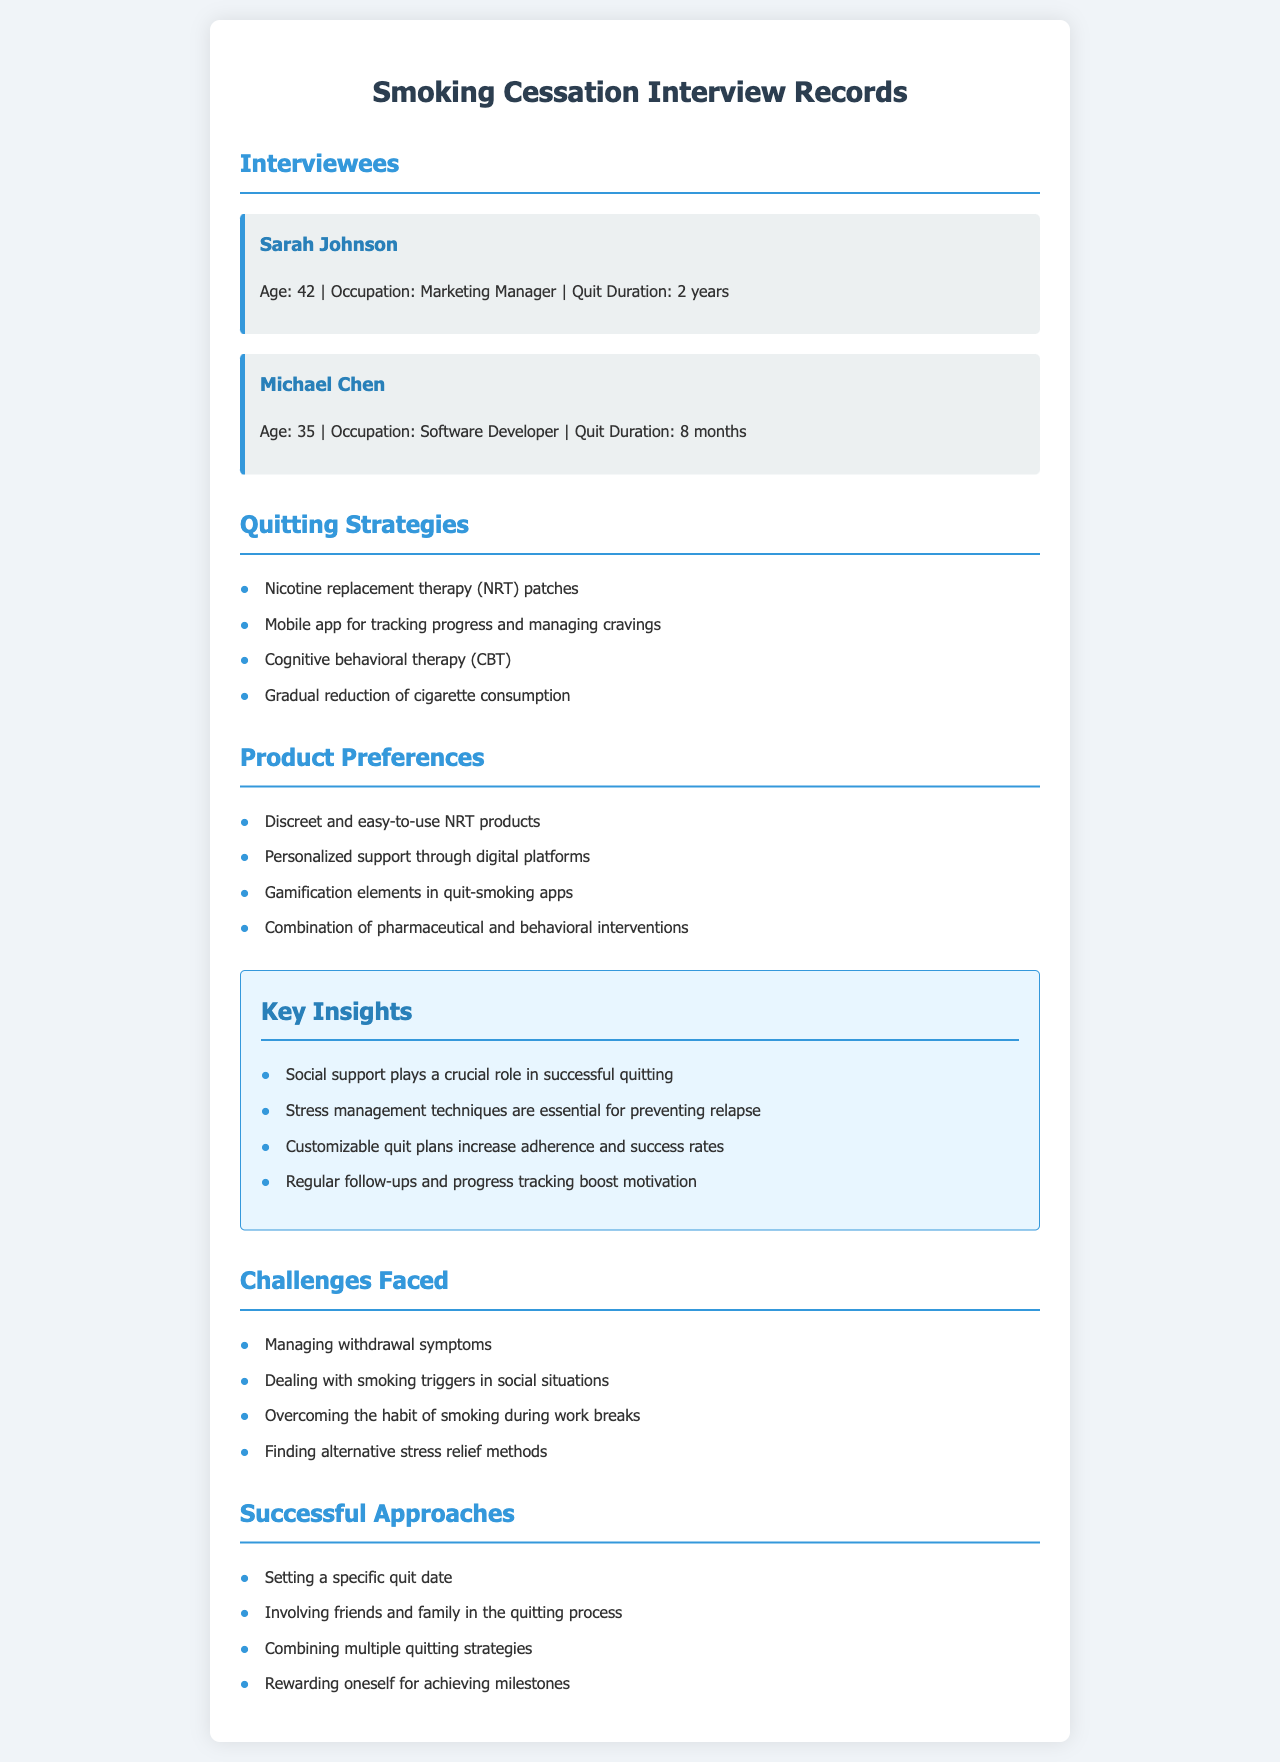what is the name of the first interviewee? The first interviewee is Sarah Johnson, whose details are listed at the beginning of the document.
Answer: Sarah Johnson how long has Michael Chen been quit? Michael Chen's quit duration is specifically mentioned in the document.
Answer: 8 months which quitting strategy involves tracking progress? The document lists strategies and mentions a mobile app for tracking progress.
Answer: Mobile app for tracking progress and managing cravings what product preference includes gamification? The document states preferences for quit-smoking apps with gamification elements.
Answer: Gamification elements in quit-smoking apps what challenge relates to social situations? The document mentions dealing with smoking triggers in social situations as a challenge faced by interviewees.
Answer: Dealing with smoking triggers in social situations how many key insights are listed? The document includes a section titled Key Insights, which mentions specific insights, and can be counted.
Answer: 4 which strategy involves friends and family? In the Successful Approaches section, it's noted that involving friends and family helps in quitting.
Answer: Involving friends and family in the quitting process what workplace habit do the interviewees mention? The challenges faced include a specific habit related to work breaks.
Answer: Smoking during work breaks 